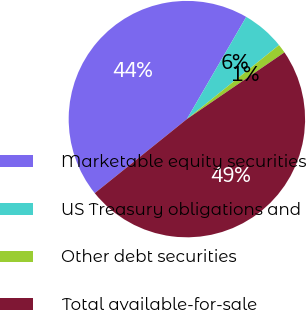Convert chart to OTSL. <chart><loc_0><loc_0><loc_500><loc_500><pie_chart><fcel>Marketable equity securities<fcel>US Treasury obligations and<fcel>Other debt securities<fcel>Total available-for-sale<nl><fcel>44.15%<fcel>5.85%<fcel>1.23%<fcel>48.77%<nl></chart> 